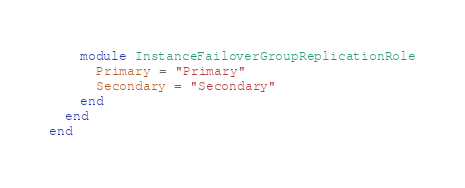Convert code to text. <code><loc_0><loc_0><loc_500><loc_500><_Ruby_>    module InstanceFailoverGroupReplicationRole
      Primary = "Primary"
      Secondary = "Secondary"
    end
  end
end
</code> 